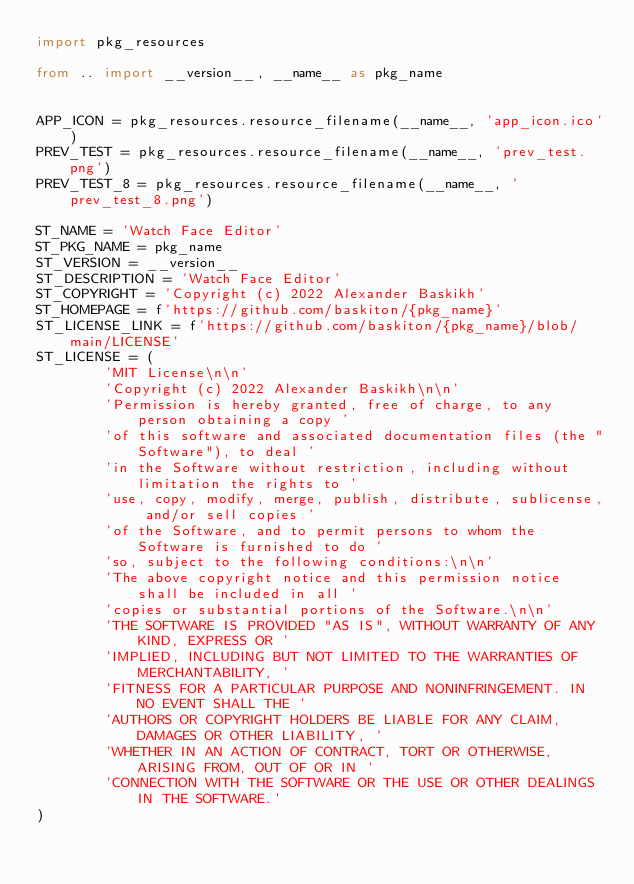Convert code to text. <code><loc_0><loc_0><loc_500><loc_500><_Python_>import pkg_resources

from .. import __version__, __name__ as pkg_name


APP_ICON = pkg_resources.resource_filename(__name__, 'app_icon.ico')
PREV_TEST = pkg_resources.resource_filename(__name__, 'prev_test.png')
PREV_TEST_8 = pkg_resources.resource_filename(__name__, 'prev_test_8.png')

ST_NAME = 'Watch Face Editor'
ST_PKG_NAME = pkg_name
ST_VERSION = __version__
ST_DESCRIPTION = 'Watch Face Editor'
ST_COPYRIGHT = 'Copyright (c) 2022 Alexander Baskikh'
ST_HOMEPAGE = f'https://github.com/baskiton/{pkg_name}'
ST_LICENSE_LINK = f'https://github.com/baskiton/{pkg_name}/blob/main/LICENSE'
ST_LICENSE = (
        'MIT License\n\n'
        'Copyright (c) 2022 Alexander Baskikh\n\n'
        'Permission is hereby granted, free of charge, to any person obtaining a copy '
        'of this software and associated documentation files (the "Software"), to deal '
        'in the Software without restriction, including without limitation the rights to '
        'use, copy, modify, merge, publish, distribute, sublicense, and/or sell copies '
        'of the Software, and to permit persons to whom the Software is furnished to do '
        'so, subject to the following conditions:\n\n'
        'The above copyright notice and this permission notice shall be included in all '
        'copies or substantial portions of the Software.\n\n'
        'THE SOFTWARE IS PROVIDED "AS IS", WITHOUT WARRANTY OF ANY KIND, EXPRESS OR '
        'IMPLIED, INCLUDING BUT NOT LIMITED TO THE WARRANTIES OF MERCHANTABILITY, '
        'FITNESS FOR A PARTICULAR PURPOSE AND NONINFRINGEMENT. IN NO EVENT SHALL THE '
        'AUTHORS OR COPYRIGHT HOLDERS BE LIABLE FOR ANY CLAIM, DAMAGES OR OTHER LIABILITY, '
        'WHETHER IN AN ACTION OF CONTRACT, TORT OR OTHERWISE, ARISING FROM, OUT OF OR IN '
        'CONNECTION WITH THE SOFTWARE OR THE USE OR OTHER DEALINGS IN THE SOFTWARE.'
)
</code> 